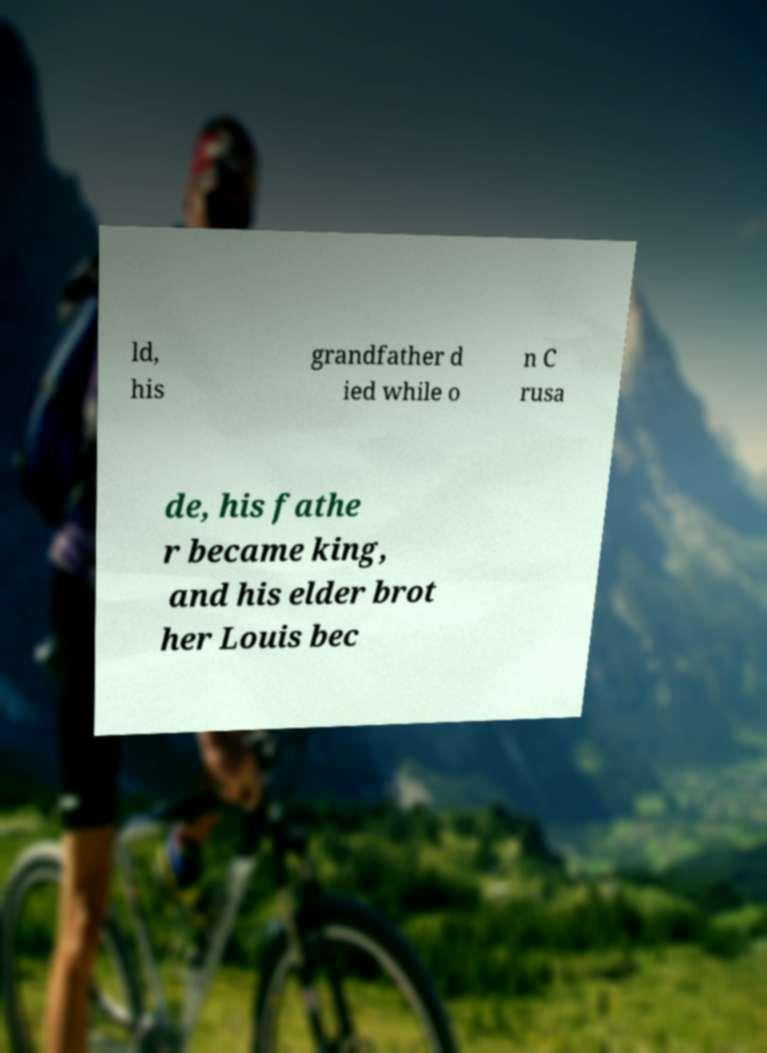Could you assist in decoding the text presented in this image and type it out clearly? ld, his grandfather d ied while o n C rusa de, his fathe r became king, and his elder brot her Louis bec 